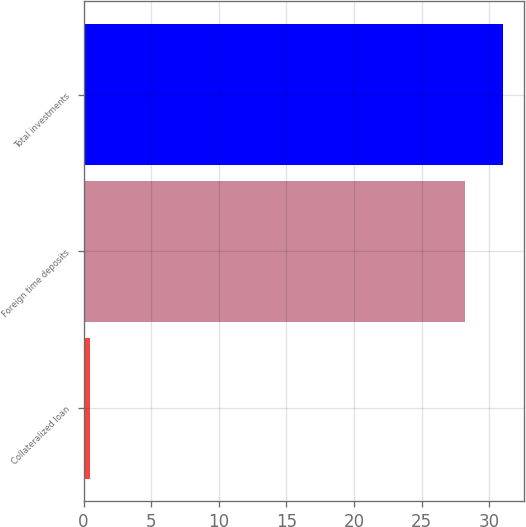Convert chart to OTSL. <chart><loc_0><loc_0><loc_500><loc_500><bar_chart><fcel>Collateralized loan<fcel>Foreign time deposits<fcel>Total investments<nl><fcel>0.5<fcel>28.2<fcel>31.02<nl></chart> 